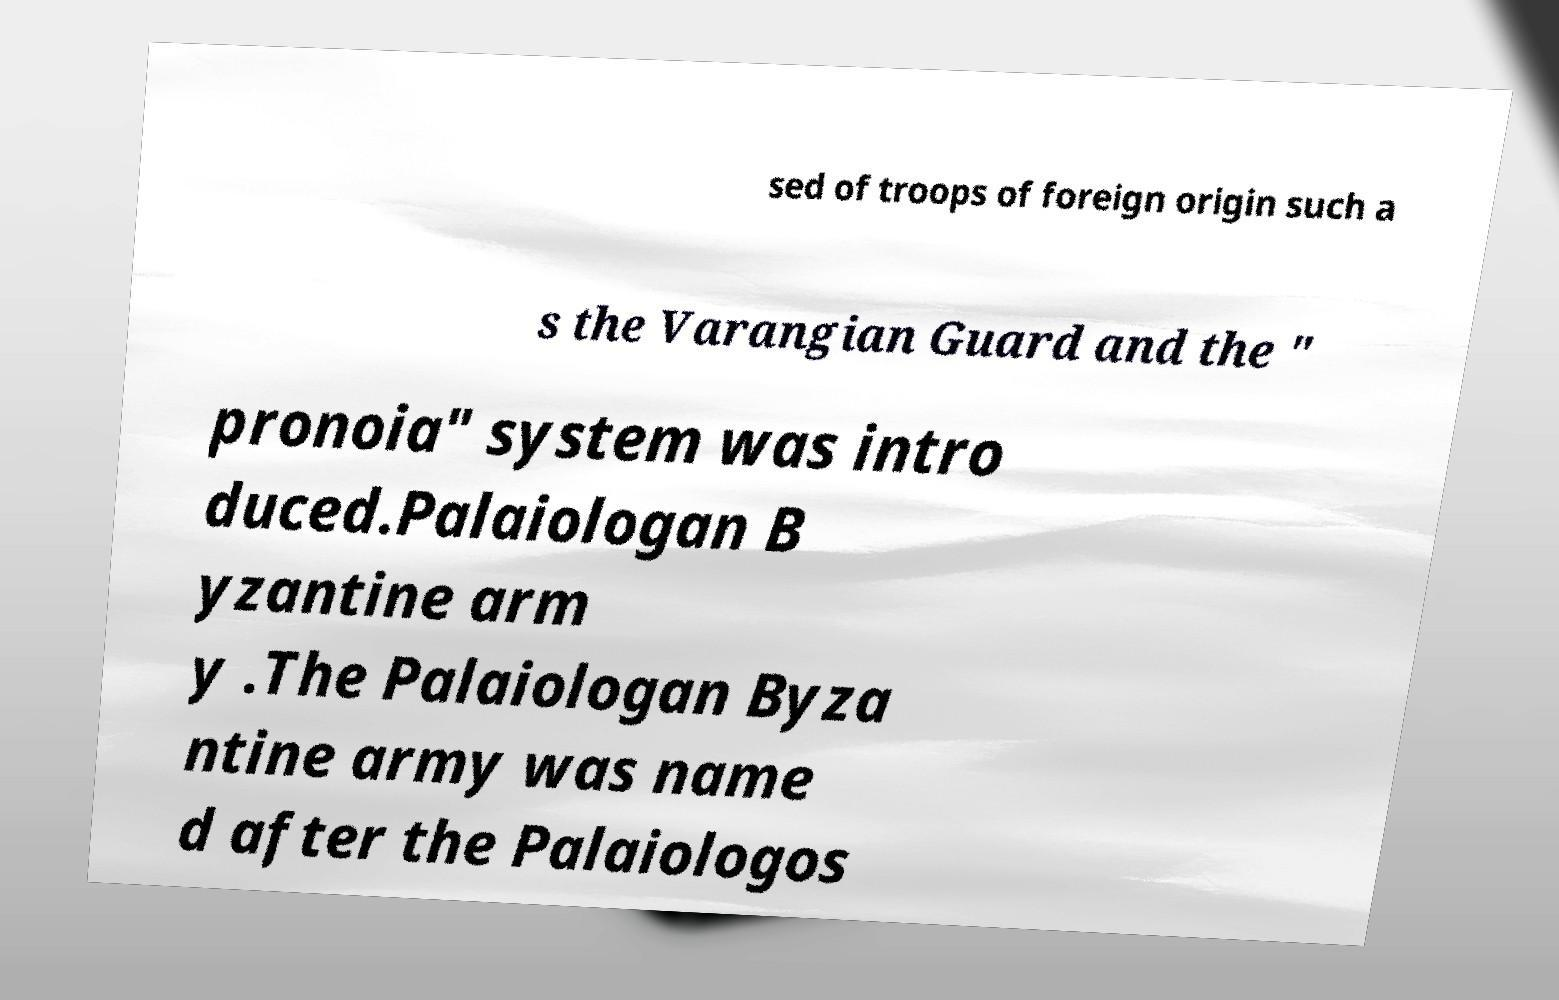Could you assist in decoding the text presented in this image and type it out clearly? sed of troops of foreign origin such a s the Varangian Guard and the " pronoia" system was intro duced.Palaiologan B yzantine arm y .The Palaiologan Byza ntine army was name d after the Palaiologos 